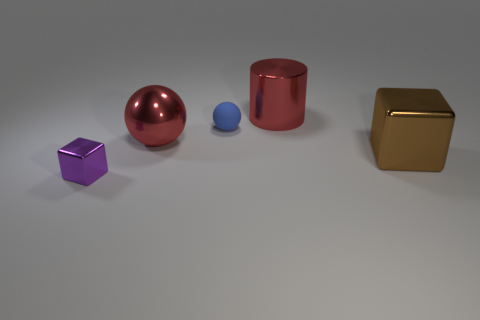Do the big object that is to the left of the metal cylinder and the metallic object behind the small matte sphere have the same color?
Provide a short and direct response. Yes. There is a metallic object that is the same color as the cylinder; what shape is it?
Provide a succinct answer. Sphere. How many other objects are there of the same material as the tiny cube?
Your answer should be compact. 3. What is the size of the metal sphere?
Provide a succinct answer. Large. Is there another tiny rubber thing that has the same shape as the brown object?
Keep it short and to the point. No. How many things are tiny red matte blocks or large objects in front of the matte ball?
Make the answer very short. 2. There is a large shiny object behind the big red metallic sphere; what is its color?
Provide a succinct answer. Red. Does the shiny block that is left of the large brown metal object have the same size as the block right of the metal cylinder?
Your answer should be very brief. No. Is there a green metal cube that has the same size as the metal sphere?
Your answer should be very brief. No. How many big metallic spheres are right of the big metal thing that is left of the big red shiny cylinder?
Offer a terse response. 0. 